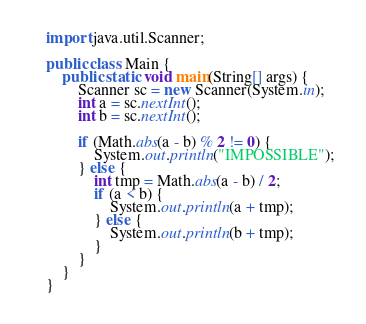Convert code to text. <code><loc_0><loc_0><loc_500><loc_500><_Java_>import java.util.Scanner;

public class Main {
    public static void main(String[] args) {
        Scanner sc = new Scanner(System.in);
        int a = sc.nextInt();
        int b = sc.nextInt();

        if (Math.abs(a - b) % 2 != 0) {
            System.out.println("IMPOSSIBLE");
        } else {
            int tmp = Math.abs(a - b) / 2;
            if (a < b) {
                System.out.println(a + tmp);
            } else {
                System.out.println(b + tmp);
            }
        }
    }
}
</code> 